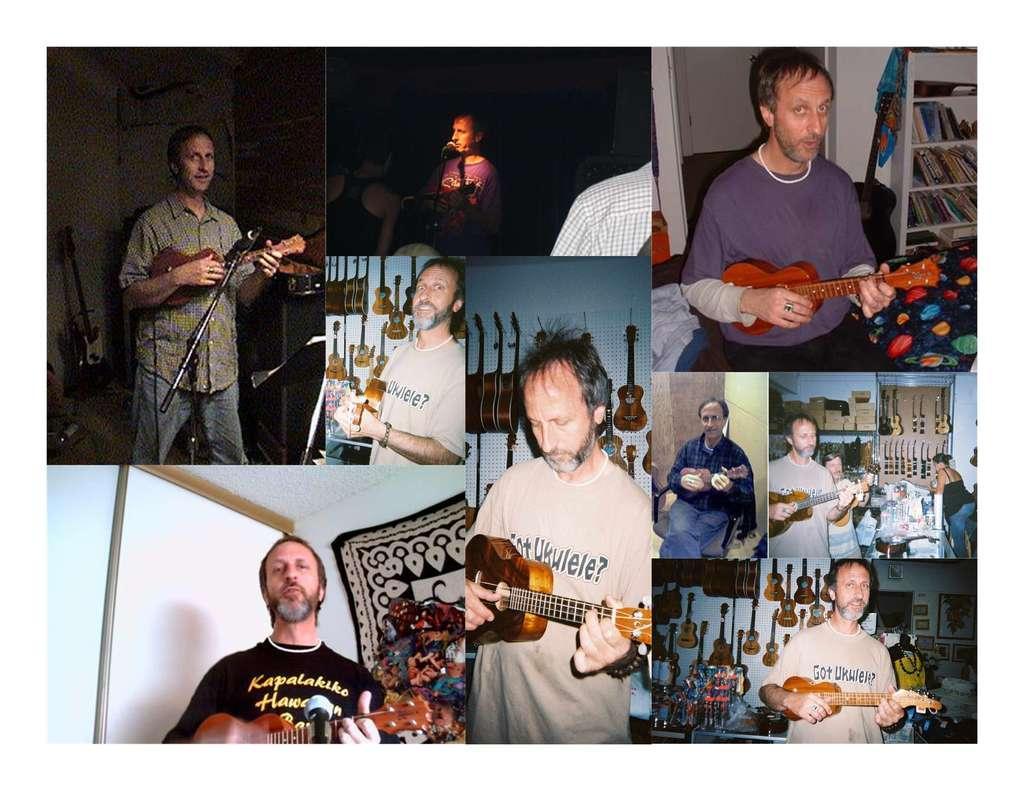How would you summarize this image in a sentence or two? In the image which is the collage of pictures in which there is a man who is standing and holding guitar in his hand. 